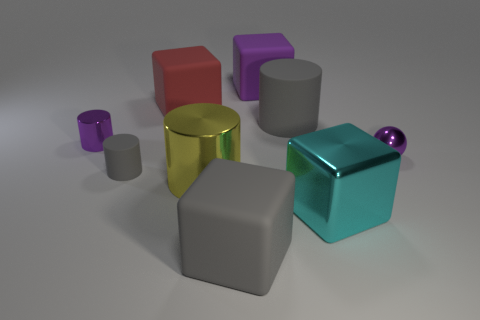How big is the purple cylinder?
Keep it short and to the point. Small. Do the tiny purple thing left of the tiny gray rubber cylinder and the gray object that is to the left of the yellow shiny object have the same material?
Give a very brief answer. No. Are there any big rubber cylinders that have the same color as the metal block?
Provide a succinct answer. No. The metal cylinder that is the same size as the red matte block is what color?
Give a very brief answer. Yellow. Is the color of the large thing that is in front of the cyan block the same as the big metallic cube?
Your answer should be very brief. No. Is there a cylinder made of the same material as the cyan block?
Give a very brief answer. Yes. There is a big object that is the same color as the ball; what shape is it?
Ensure brevity in your answer.  Cube. Are there fewer big purple things behind the yellow metal cylinder than red blocks?
Provide a succinct answer. No. Is the size of the gray thing that is behind the purple cylinder the same as the large yellow shiny object?
Your answer should be compact. Yes. How many big gray objects are the same shape as the yellow metal thing?
Provide a short and direct response. 1. 